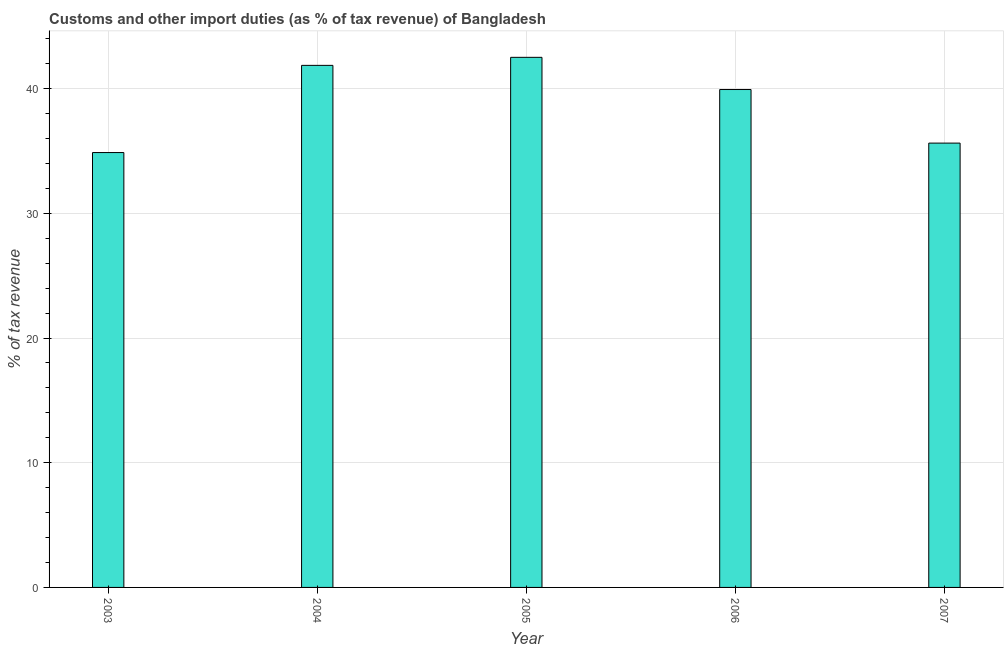What is the title of the graph?
Your answer should be compact. Customs and other import duties (as % of tax revenue) of Bangladesh. What is the label or title of the Y-axis?
Give a very brief answer. % of tax revenue. What is the customs and other import duties in 2004?
Ensure brevity in your answer.  41.87. Across all years, what is the maximum customs and other import duties?
Your answer should be very brief. 42.51. Across all years, what is the minimum customs and other import duties?
Your response must be concise. 34.87. In which year was the customs and other import duties maximum?
Provide a succinct answer. 2005. In which year was the customs and other import duties minimum?
Make the answer very short. 2003. What is the sum of the customs and other import duties?
Make the answer very short. 194.82. What is the difference between the customs and other import duties in 2003 and 2006?
Your answer should be compact. -5.05. What is the average customs and other import duties per year?
Make the answer very short. 38.96. What is the median customs and other import duties?
Your answer should be compact. 39.93. Do a majority of the years between 2007 and 2004 (inclusive) have customs and other import duties greater than 16 %?
Offer a terse response. Yes. What is the ratio of the customs and other import duties in 2003 to that in 2005?
Keep it short and to the point. 0.82. Is the customs and other import duties in 2005 less than that in 2006?
Provide a short and direct response. No. What is the difference between the highest and the second highest customs and other import duties?
Keep it short and to the point. 0.65. Is the sum of the customs and other import duties in 2003 and 2004 greater than the maximum customs and other import duties across all years?
Provide a short and direct response. Yes. What is the difference between the highest and the lowest customs and other import duties?
Provide a succinct answer. 7.64. In how many years, is the customs and other import duties greater than the average customs and other import duties taken over all years?
Your answer should be very brief. 3. Are all the bars in the graph horizontal?
Make the answer very short. No. Are the values on the major ticks of Y-axis written in scientific E-notation?
Your answer should be very brief. No. What is the % of tax revenue in 2003?
Your answer should be very brief. 34.87. What is the % of tax revenue in 2004?
Offer a very short reply. 41.87. What is the % of tax revenue in 2005?
Provide a short and direct response. 42.51. What is the % of tax revenue of 2006?
Your answer should be very brief. 39.93. What is the % of tax revenue in 2007?
Ensure brevity in your answer.  35.63. What is the difference between the % of tax revenue in 2003 and 2004?
Ensure brevity in your answer.  -6.99. What is the difference between the % of tax revenue in 2003 and 2005?
Provide a succinct answer. -7.64. What is the difference between the % of tax revenue in 2003 and 2006?
Provide a short and direct response. -5.05. What is the difference between the % of tax revenue in 2003 and 2007?
Your response must be concise. -0.76. What is the difference between the % of tax revenue in 2004 and 2005?
Your answer should be very brief. -0.64. What is the difference between the % of tax revenue in 2004 and 2006?
Make the answer very short. 1.94. What is the difference between the % of tax revenue in 2004 and 2007?
Make the answer very short. 6.23. What is the difference between the % of tax revenue in 2005 and 2006?
Provide a short and direct response. 2.58. What is the difference between the % of tax revenue in 2005 and 2007?
Offer a terse response. 6.88. What is the difference between the % of tax revenue in 2006 and 2007?
Ensure brevity in your answer.  4.3. What is the ratio of the % of tax revenue in 2003 to that in 2004?
Make the answer very short. 0.83. What is the ratio of the % of tax revenue in 2003 to that in 2005?
Your response must be concise. 0.82. What is the ratio of the % of tax revenue in 2003 to that in 2006?
Your response must be concise. 0.87. What is the ratio of the % of tax revenue in 2004 to that in 2005?
Ensure brevity in your answer.  0.98. What is the ratio of the % of tax revenue in 2004 to that in 2006?
Ensure brevity in your answer.  1.05. What is the ratio of the % of tax revenue in 2004 to that in 2007?
Your answer should be very brief. 1.18. What is the ratio of the % of tax revenue in 2005 to that in 2006?
Your answer should be compact. 1.06. What is the ratio of the % of tax revenue in 2005 to that in 2007?
Your response must be concise. 1.19. What is the ratio of the % of tax revenue in 2006 to that in 2007?
Ensure brevity in your answer.  1.12. 